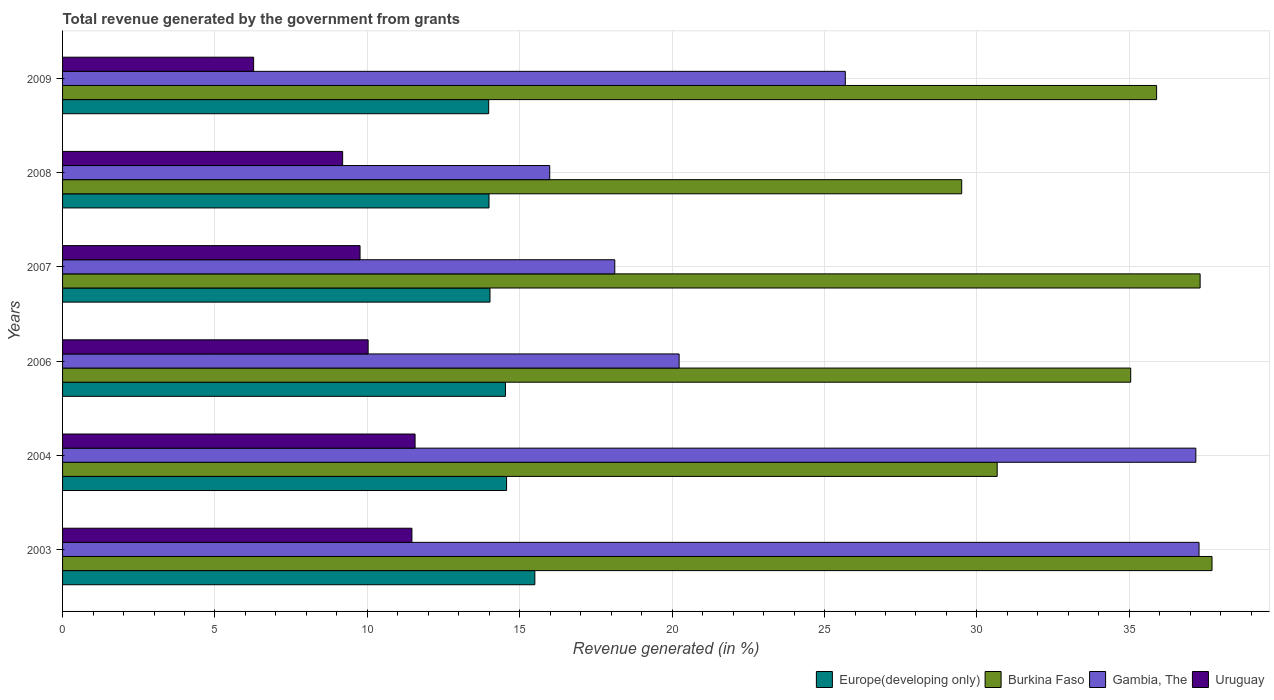How many different coloured bars are there?
Give a very brief answer. 4. Are the number of bars per tick equal to the number of legend labels?
Your response must be concise. Yes. Are the number of bars on each tick of the Y-axis equal?
Give a very brief answer. Yes. How many bars are there on the 4th tick from the top?
Provide a short and direct response. 4. In how many cases, is the number of bars for a given year not equal to the number of legend labels?
Make the answer very short. 0. What is the total revenue generated in Uruguay in 2003?
Your answer should be very brief. 11.46. Across all years, what is the maximum total revenue generated in Burkina Faso?
Ensure brevity in your answer.  37.71. Across all years, what is the minimum total revenue generated in Uruguay?
Give a very brief answer. 6.27. In which year was the total revenue generated in Europe(developing only) minimum?
Provide a succinct answer. 2009. What is the total total revenue generated in Burkina Faso in the graph?
Your response must be concise. 206.14. What is the difference between the total revenue generated in Burkina Faso in 2003 and that in 2006?
Keep it short and to the point. 2.67. What is the difference between the total revenue generated in Gambia, The in 2006 and the total revenue generated in Uruguay in 2007?
Ensure brevity in your answer.  10.47. What is the average total revenue generated in Burkina Faso per year?
Ensure brevity in your answer.  34.36. In the year 2008, what is the difference between the total revenue generated in Uruguay and total revenue generated in Gambia, The?
Your answer should be very brief. -6.79. What is the ratio of the total revenue generated in Gambia, The in 2004 to that in 2007?
Provide a succinct answer. 2.05. Is the total revenue generated in Gambia, The in 2004 less than that in 2009?
Keep it short and to the point. No. What is the difference between the highest and the second highest total revenue generated in Europe(developing only)?
Make the answer very short. 0.93. What is the difference between the highest and the lowest total revenue generated in Gambia, The?
Give a very brief answer. 21.3. Is it the case that in every year, the sum of the total revenue generated in Europe(developing only) and total revenue generated in Uruguay is greater than the sum of total revenue generated in Gambia, The and total revenue generated in Burkina Faso?
Your answer should be compact. No. What does the 1st bar from the top in 2003 represents?
Give a very brief answer. Uruguay. What does the 3rd bar from the bottom in 2008 represents?
Your answer should be very brief. Gambia, The. How many bars are there?
Your answer should be compact. 24. Are all the bars in the graph horizontal?
Offer a terse response. Yes. What is the difference between two consecutive major ticks on the X-axis?
Offer a very short reply. 5. Does the graph contain grids?
Your answer should be very brief. Yes. How many legend labels are there?
Your answer should be very brief. 4. What is the title of the graph?
Your answer should be compact. Total revenue generated by the government from grants. What is the label or title of the X-axis?
Give a very brief answer. Revenue generated (in %). What is the Revenue generated (in %) in Europe(developing only) in 2003?
Your response must be concise. 15.5. What is the Revenue generated (in %) of Burkina Faso in 2003?
Keep it short and to the point. 37.71. What is the Revenue generated (in %) of Gambia, The in 2003?
Provide a short and direct response. 37.29. What is the Revenue generated (in %) of Uruguay in 2003?
Offer a very short reply. 11.46. What is the Revenue generated (in %) in Europe(developing only) in 2004?
Your response must be concise. 14.57. What is the Revenue generated (in %) of Burkina Faso in 2004?
Your answer should be compact. 30.66. What is the Revenue generated (in %) in Gambia, The in 2004?
Provide a succinct answer. 37.18. What is the Revenue generated (in %) of Uruguay in 2004?
Offer a terse response. 11.57. What is the Revenue generated (in %) of Europe(developing only) in 2006?
Offer a terse response. 14.53. What is the Revenue generated (in %) in Burkina Faso in 2006?
Your response must be concise. 35.05. What is the Revenue generated (in %) of Gambia, The in 2006?
Your answer should be very brief. 20.23. What is the Revenue generated (in %) in Uruguay in 2006?
Provide a short and direct response. 10.03. What is the Revenue generated (in %) of Europe(developing only) in 2007?
Make the answer very short. 14.02. What is the Revenue generated (in %) in Burkina Faso in 2007?
Offer a terse response. 37.32. What is the Revenue generated (in %) in Gambia, The in 2007?
Offer a terse response. 18.12. What is the Revenue generated (in %) in Uruguay in 2007?
Make the answer very short. 9.76. What is the Revenue generated (in %) in Europe(developing only) in 2008?
Keep it short and to the point. 13.99. What is the Revenue generated (in %) of Burkina Faso in 2008?
Your response must be concise. 29.5. What is the Revenue generated (in %) in Gambia, The in 2008?
Give a very brief answer. 15.98. What is the Revenue generated (in %) in Uruguay in 2008?
Your response must be concise. 9.19. What is the Revenue generated (in %) of Europe(developing only) in 2009?
Provide a succinct answer. 13.98. What is the Revenue generated (in %) in Burkina Faso in 2009?
Make the answer very short. 35.9. What is the Revenue generated (in %) of Gambia, The in 2009?
Your answer should be compact. 25.68. What is the Revenue generated (in %) of Uruguay in 2009?
Provide a short and direct response. 6.27. Across all years, what is the maximum Revenue generated (in %) in Europe(developing only)?
Offer a very short reply. 15.5. Across all years, what is the maximum Revenue generated (in %) in Burkina Faso?
Your answer should be very brief. 37.71. Across all years, what is the maximum Revenue generated (in %) of Gambia, The?
Provide a succinct answer. 37.29. Across all years, what is the maximum Revenue generated (in %) in Uruguay?
Provide a succinct answer. 11.57. Across all years, what is the minimum Revenue generated (in %) in Europe(developing only)?
Offer a terse response. 13.98. Across all years, what is the minimum Revenue generated (in %) in Burkina Faso?
Provide a short and direct response. 29.5. Across all years, what is the minimum Revenue generated (in %) in Gambia, The?
Keep it short and to the point. 15.98. Across all years, what is the minimum Revenue generated (in %) in Uruguay?
Your answer should be very brief. 6.27. What is the total Revenue generated (in %) in Europe(developing only) in the graph?
Offer a terse response. 86.59. What is the total Revenue generated (in %) in Burkina Faso in the graph?
Offer a terse response. 206.14. What is the total Revenue generated (in %) in Gambia, The in the graph?
Offer a very short reply. 154.48. What is the total Revenue generated (in %) in Uruguay in the graph?
Offer a terse response. 58.27. What is the difference between the Revenue generated (in %) of Europe(developing only) in 2003 and that in 2004?
Your answer should be very brief. 0.93. What is the difference between the Revenue generated (in %) in Burkina Faso in 2003 and that in 2004?
Provide a short and direct response. 7.05. What is the difference between the Revenue generated (in %) of Gambia, The in 2003 and that in 2004?
Your answer should be compact. 0.11. What is the difference between the Revenue generated (in %) of Uruguay in 2003 and that in 2004?
Provide a short and direct response. -0.1. What is the difference between the Revenue generated (in %) in Europe(developing only) in 2003 and that in 2006?
Make the answer very short. 0.96. What is the difference between the Revenue generated (in %) of Burkina Faso in 2003 and that in 2006?
Provide a short and direct response. 2.67. What is the difference between the Revenue generated (in %) of Gambia, The in 2003 and that in 2006?
Give a very brief answer. 17.06. What is the difference between the Revenue generated (in %) in Uruguay in 2003 and that in 2006?
Offer a terse response. 1.44. What is the difference between the Revenue generated (in %) in Europe(developing only) in 2003 and that in 2007?
Ensure brevity in your answer.  1.47. What is the difference between the Revenue generated (in %) of Burkina Faso in 2003 and that in 2007?
Provide a succinct answer. 0.39. What is the difference between the Revenue generated (in %) of Gambia, The in 2003 and that in 2007?
Your answer should be compact. 19.17. What is the difference between the Revenue generated (in %) of Uruguay in 2003 and that in 2007?
Provide a succinct answer. 1.7. What is the difference between the Revenue generated (in %) of Europe(developing only) in 2003 and that in 2008?
Offer a terse response. 1.5. What is the difference between the Revenue generated (in %) in Burkina Faso in 2003 and that in 2008?
Your answer should be compact. 8.21. What is the difference between the Revenue generated (in %) in Gambia, The in 2003 and that in 2008?
Your answer should be very brief. 21.3. What is the difference between the Revenue generated (in %) of Uruguay in 2003 and that in 2008?
Provide a succinct answer. 2.27. What is the difference between the Revenue generated (in %) in Europe(developing only) in 2003 and that in 2009?
Your answer should be compact. 1.51. What is the difference between the Revenue generated (in %) of Burkina Faso in 2003 and that in 2009?
Ensure brevity in your answer.  1.82. What is the difference between the Revenue generated (in %) in Gambia, The in 2003 and that in 2009?
Make the answer very short. 11.61. What is the difference between the Revenue generated (in %) of Uruguay in 2003 and that in 2009?
Make the answer very short. 5.19. What is the difference between the Revenue generated (in %) in Europe(developing only) in 2004 and that in 2006?
Your response must be concise. 0.04. What is the difference between the Revenue generated (in %) in Burkina Faso in 2004 and that in 2006?
Provide a short and direct response. -4.38. What is the difference between the Revenue generated (in %) of Gambia, The in 2004 and that in 2006?
Offer a terse response. 16.95. What is the difference between the Revenue generated (in %) of Uruguay in 2004 and that in 2006?
Ensure brevity in your answer.  1.54. What is the difference between the Revenue generated (in %) in Europe(developing only) in 2004 and that in 2007?
Your answer should be compact. 0.54. What is the difference between the Revenue generated (in %) of Burkina Faso in 2004 and that in 2007?
Your answer should be very brief. -6.66. What is the difference between the Revenue generated (in %) in Gambia, The in 2004 and that in 2007?
Give a very brief answer. 19.06. What is the difference between the Revenue generated (in %) of Uruguay in 2004 and that in 2007?
Provide a succinct answer. 1.81. What is the difference between the Revenue generated (in %) in Europe(developing only) in 2004 and that in 2008?
Your response must be concise. 0.58. What is the difference between the Revenue generated (in %) in Burkina Faso in 2004 and that in 2008?
Your answer should be compact. 1.16. What is the difference between the Revenue generated (in %) in Gambia, The in 2004 and that in 2008?
Keep it short and to the point. 21.2. What is the difference between the Revenue generated (in %) in Uruguay in 2004 and that in 2008?
Keep it short and to the point. 2.38. What is the difference between the Revenue generated (in %) in Europe(developing only) in 2004 and that in 2009?
Your answer should be very brief. 0.59. What is the difference between the Revenue generated (in %) of Burkina Faso in 2004 and that in 2009?
Your answer should be very brief. -5.23. What is the difference between the Revenue generated (in %) of Gambia, The in 2004 and that in 2009?
Keep it short and to the point. 11.5. What is the difference between the Revenue generated (in %) in Uruguay in 2004 and that in 2009?
Provide a short and direct response. 5.3. What is the difference between the Revenue generated (in %) of Europe(developing only) in 2006 and that in 2007?
Make the answer very short. 0.51. What is the difference between the Revenue generated (in %) in Burkina Faso in 2006 and that in 2007?
Provide a short and direct response. -2.28. What is the difference between the Revenue generated (in %) in Gambia, The in 2006 and that in 2007?
Ensure brevity in your answer.  2.11. What is the difference between the Revenue generated (in %) in Uruguay in 2006 and that in 2007?
Your response must be concise. 0.27. What is the difference between the Revenue generated (in %) in Europe(developing only) in 2006 and that in 2008?
Keep it short and to the point. 0.54. What is the difference between the Revenue generated (in %) of Burkina Faso in 2006 and that in 2008?
Make the answer very short. 5.55. What is the difference between the Revenue generated (in %) in Gambia, The in 2006 and that in 2008?
Provide a succinct answer. 4.25. What is the difference between the Revenue generated (in %) in Uruguay in 2006 and that in 2008?
Your answer should be compact. 0.84. What is the difference between the Revenue generated (in %) in Europe(developing only) in 2006 and that in 2009?
Provide a succinct answer. 0.55. What is the difference between the Revenue generated (in %) of Burkina Faso in 2006 and that in 2009?
Ensure brevity in your answer.  -0.85. What is the difference between the Revenue generated (in %) in Gambia, The in 2006 and that in 2009?
Your answer should be very brief. -5.45. What is the difference between the Revenue generated (in %) in Uruguay in 2006 and that in 2009?
Your answer should be very brief. 3.76. What is the difference between the Revenue generated (in %) of Europe(developing only) in 2007 and that in 2008?
Provide a short and direct response. 0.03. What is the difference between the Revenue generated (in %) of Burkina Faso in 2007 and that in 2008?
Your response must be concise. 7.82. What is the difference between the Revenue generated (in %) in Gambia, The in 2007 and that in 2008?
Ensure brevity in your answer.  2.13. What is the difference between the Revenue generated (in %) in Uruguay in 2007 and that in 2008?
Ensure brevity in your answer.  0.57. What is the difference between the Revenue generated (in %) in Europe(developing only) in 2007 and that in 2009?
Give a very brief answer. 0.04. What is the difference between the Revenue generated (in %) of Burkina Faso in 2007 and that in 2009?
Offer a very short reply. 1.43. What is the difference between the Revenue generated (in %) in Gambia, The in 2007 and that in 2009?
Provide a short and direct response. -7.56. What is the difference between the Revenue generated (in %) in Uruguay in 2007 and that in 2009?
Keep it short and to the point. 3.49. What is the difference between the Revenue generated (in %) of Europe(developing only) in 2008 and that in 2009?
Provide a succinct answer. 0.01. What is the difference between the Revenue generated (in %) of Burkina Faso in 2008 and that in 2009?
Offer a terse response. -6.39. What is the difference between the Revenue generated (in %) of Gambia, The in 2008 and that in 2009?
Keep it short and to the point. -9.7. What is the difference between the Revenue generated (in %) of Uruguay in 2008 and that in 2009?
Provide a short and direct response. 2.92. What is the difference between the Revenue generated (in %) of Europe(developing only) in 2003 and the Revenue generated (in %) of Burkina Faso in 2004?
Provide a short and direct response. -15.17. What is the difference between the Revenue generated (in %) in Europe(developing only) in 2003 and the Revenue generated (in %) in Gambia, The in 2004?
Your answer should be compact. -21.69. What is the difference between the Revenue generated (in %) of Europe(developing only) in 2003 and the Revenue generated (in %) of Uruguay in 2004?
Ensure brevity in your answer.  3.93. What is the difference between the Revenue generated (in %) in Burkina Faso in 2003 and the Revenue generated (in %) in Gambia, The in 2004?
Give a very brief answer. 0.53. What is the difference between the Revenue generated (in %) of Burkina Faso in 2003 and the Revenue generated (in %) of Uruguay in 2004?
Provide a short and direct response. 26.15. What is the difference between the Revenue generated (in %) in Gambia, The in 2003 and the Revenue generated (in %) in Uruguay in 2004?
Ensure brevity in your answer.  25.72. What is the difference between the Revenue generated (in %) in Europe(developing only) in 2003 and the Revenue generated (in %) in Burkina Faso in 2006?
Provide a short and direct response. -19.55. What is the difference between the Revenue generated (in %) of Europe(developing only) in 2003 and the Revenue generated (in %) of Gambia, The in 2006?
Your answer should be very brief. -4.73. What is the difference between the Revenue generated (in %) in Europe(developing only) in 2003 and the Revenue generated (in %) in Uruguay in 2006?
Make the answer very short. 5.47. What is the difference between the Revenue generated (in %) of Burkina Faso in 2003 and the Revenue generated (in %) of Gambia, The in 2006?
Give a very brief answer. 17.48. What is the difference between the Revenue generated (in %) in Burkina Faso in 2003 and the Revenue generated (in %) in Uruguay in 2006?
Your answer should be very brief. 27.69. What is the difference between the Revenue generated (in %) of Gambia, The in 2003 and the Revenue generated (in %) of Uruguay in 2006?
Offer a very short reply. 27.26. What is the difference between the Revenue generated (in %) in Europe(developing only) in 2003 and the Revenue generated (in %) in Burkina Faso in 2007?
Provide a succinct answer. -21.83. What is the difference between the Revenue generated (in %) in Europe(developing only) in 2003 and the Revenue generated (in %) in Gambia, The in 2007?
Your answer should be very brief. -2.62. What is the difference between the Revenue generated (in %) in Europe(developing only) in 2003 and the Revenue generated (in %) in Uruguay in 2007?
Your answer should be very brief. 5.73. What is the difference between the Revenue generated (in %) of Burkina Faso in 2003 and the Revenue generated (in %) of Gambia, The in 2007?
Provide a succinct answer. 19.6. What is the difference between the Revenue generated (in %) of Burkina Faso in 2003 and the Revenue generated (in %) of Uruguay in 2007?
Provide a succinct answer. 27.95. What is the difference between the Revenue generated (in %) in Gambia, The in 2003 and the Revenue generated (in %) in Uruguay in 2007?
Make the answer very short. 27.53. What is the difference between the Revenue generated (in %) in Europe(developing only) in 2003 and the Revenue generated (in %) in Burkina Faso in 2008?
Offer a very short reply. -14.01. What is the difference between the Revenue generated (in %) in Europe(developing only) in 2003 and the Revenue generated (in %) in Gambia, The in 2008?
Your answer should be very brief. -0.49. What is the difference between the Revenue generated (in %) of Europe(developing only) in 2003 and the Revenue generated (in %) of Uruguay in 2008?
Keep it short and to the point. 6.31. What is the difference between the Revenue generated (in %) in Burkina Faso in 2003 and the Revenue generated (in %) in Gambia, The in 2008?
Your response must be concise. 21.73. What is the difference between the Revenue generated (in %) of Burkina Faso in 2003 and the Revenue generated (in %) of Uruguay in 2008?
Your answer should be compact. 28.52. What is the difference between the Revenue generated (in %) of Gambia, The in 2003 and the Revenue generated (in %) of Uruguay in 2008?
Offer a very short reply. 28.1. What is the difference between the Revenue generated (in %) in Europe(developing only) in 2003 and the Revenue generated (in %) in Burkina Faso in 2009?
Offer a very short reply. -20.4. What is the difference between the Revenue generated (in %) in Europe(developing only) in 2003 and the Revenue generated (in %) in Gambia, The in 2009?
Your answer should be compact. -10.19. What is the difference between the Revenue generated (in %) in Europe(developing only) in 2003 and the Revenue generated (in %) in Uruguay in 2009?
Provide a succinct answer. 9.23. What is the difference between the Revenue generated (in %) of Burkina Faso in 2003 and the Revenue generated (in %) of Gambia, The in 2009?
Offer a terse response. 12.03. What is the difference between the Revenue generated (in %) of Burkina Faso in 2003 and the Revenue generated (in %) of Uruguay in 2009?
Ensure brevity in your answer.  31.44. What is the difference between the Revenue generated (in %) in Gambia, The in 2003 and the Revenue generated (in %) in Uruguay in 2009?
Give a very brief answer. 31.02. What is the difference between the Revenue generated (in %) in Europe(developing only) in 2004 and the Revenue generated (in %) in Burkina Faso in 2006?
Give a very brief answer. -20.48. What is the difference between the Revenue generated (in %) in Europe(developing only) in 2004 and the Revenue generated (in %) in Gambia, The in 2006?
Ensure brevity in your answer.  -5.66. What is the difference between the Revenue generated (in %) of Europe(developing only) in 2004 and the Revenue generated (in %) of Uruguay in 2006?
Give a very brief answer. 4.54. What is the difference between the Revenue generated (in %) of Burkina Faso in 2004 and the Revenue generated (in %) of Gambia, The in 2006?
Your answer should be very brief. 10.44. What is the difference between the Revenue generated (in %) of Burkina Faso in 2004 and the Revenue generated (in %) of Uruguay in 2006?
Offer a terse response. 20.64. What is the difference between the Revenue generated (in %) of Gambia, The in 2004 and the Revenue generated (in %) of Uruguay in 2006?
Your answer should be compact. 27.16. What is the difference between the Revenue generated (in %) of Europe(developing only) in 2004 and the Revenue generated (in %) of Burkina Faso in 2007?
Offer a terse response. -22.76. What is the difference between the Revenue generated (in %) of Europe(developing only) in 2004 and the Revenue generated (in %) of Gambia, The in 2007?
Your response must be concise. -3.55. What is the difference between the Revenue generated (in %) of Europe(developing only) in 2004 and the Revenue generated (in %) of Uruguay in 2007?
Make the answer very short. 4.81. What is the difference between the Revenue generated (in %) in Burkina Faso in 2004 and the Revenue generated (in %) in Gambia, The in 2007?
Your answer should be compact. 12.55. What is the difference between the Revenue generated (in %) in Burkina Faso in 2004 and the Revenue generated (in %) in Uruguay in 2007?
Offer a terse response. 20.9. What is the difference between the Revenue generated (in %) of Gambia, The in 2004 and the Revenue generated (in %) of Uruguay in 2007?
Give a very brief answer. 27.42. What is the difference between the Revenue generated (in %) in Europe(developing only) in 2004 and the Revenue generated (in %) in Burkina Faso in 2008?
Your answer should be compact. -14.93. What is the difference between the Revenue generated (in %) in Europe(developing only) in 2004 and the Revenue generated (in %) in Gambia, The in 2008?
Give a very brief answer. -1.42. What is the difference between the Revenue generated (in %) of Europe(developing only) in 2004 and the Revenue generated (in %) of Uruguay in 2008?
Ensure brevity in your answer.  5.38. What is the difference between the Revenue generated (in %) in Burkina Faso in 2004 and the Revenue generated (in %) in Gambia, The in 2008?
Provide a short and direct response. 14.68. What is the difference between the Revenue generated (in %) of Burkina Faso in 2004 and the Revenue generated (in %) of Uruguay in 2008?
Make the answer very short. 21.48. What is the difference between the Revenue generated (in %) in Gambia, The in 2004 and the Revenue generated (in %) in Uruguay in 2008?
Keep it short and to the point. 27.99. What is the difference between the Revenue generated (in %) in Europe(developing only) in 2004 and the Revenue generated (in %) in Burkina Faso in 2009?
Offer a very short reply. -21.33. What is the difference between the Revenue generated (in %) of Europe(developing only) in 2004 and the Revenue generated (in %) of Gambia, The in 2009?
Your answer should be compact. -11.11. What is the difference between the Revenue generated (in %) in Europe(developing only) in 2004 and the Revenue generated (in %) in Uruguay in 2009?
Provide a succinct answer. 8.3. What is the difference between the Revenue generated (in %) in Burkina Faso in 2004 and the Revenue generated (in %) in Gambia, The in 2009?
Your response must be concise. 4.98. What is the difference between the Revenue generated (in %) in Burkina Faso in 2004 and the Revenue generated (in %) in Uruguay in 2009?
Ensure brevity in your answer.  24.4. What is the difference between the Revenue generated (in %) in Gambia, The in 2004 and the Revenue generated (in %) in Uruguay in 2009?
Ensure brevity in your answer.  30.91. What is the difference between the Revenue generated (in %) in Europe(developing only) in 2006 and the Revenue generated (in %) in Burkina Faso in 2007?
Your answer should be compact. -22.79. What is the difference between the Revenue generated (in %) in Europe(developing only) in 2006 and the Revenue generated (in %) in Gambia, The in 2007?
Provide a short and direct response. -3.59. What is the difference between the Revenue generated (in %) of Europe(developing only) in 2006 and the Revenue generated (in %) of Uruguay in 2007?
Your answer should be very brief. 4.77. What is the difference between the Revenue generated (in %) of Burkina Faso in 2006 and the Revenue generated (in %) of Gambia, The in 2007?
Keep it short and to the point. 16.93. What is the difference between the Revenue generated (in %) of Burkina Faso in 2006 and the Revenue generated (in %) of Uruguay in 2007?
Keep it short and to the point. 25.29. What is the difference between the Revenue generated (in %) in Gambia, The in 2006 and the Revenue generated (in %) in Uruguay in 2007?
Your answer should be compact. 10.47. What is the difference between the Revenue generated (in %) in Europe(developing only) in 2006 and the Revenue generated (in %) in Burkina Faso in 2008?
Give a very brief answer. -14.97. What is the difference between the Revenue generated (in %) of Europe(developing only) in 2006 and the Revenue generated (in %) of Gambia, The in 2008?
Offer a very short reply. -1.45. What is the difference between the Revenue generated (in %) in Europe(developing only) in 2006 and the Revenue generated (in %) in Uruguay in 2008?
Offer a very short reply. 5.34. What is the difference between the Revenue generated (in %) of Burkina Faso in 2006 and the Revenue generated (in %) of Gambia, The in 2008?
Provide a short and direct response. 19.06. What is the difference between the Revenue generated (in %) of Burkina Faso in 2006 and the Revenue generated (in %) of Uruguay in 2008?
Offer a terse response. 25.86. What is the difference between the Revenue generated (in %) of Gambia, The in 2006 and the Revenue generated (in %) of Uruguay in 2008?
Offer a very short reply. 11.04. What is the difference between the Revenue generated (in %) of Europe(developing only) in 2006 and the Revenue generated (in %) of Burkina Faso in 2009?
Provide a short and direct response. -21.36. What is the difference between the Revenue generated (in %) of Europe(developing only) in 2006 and the Revenue generated (in %) of Gambia, The in 2009?
Your answer should be compact. -11.15. What is the difference between the Revenue generated (in %) of Europe(developing only) in 2006 and the Revenue generated (in %) of Uruguay in 2009?
Your response must be concise. 8.26. What is the difference between the Revenue generated (in %) in Burkina Faso in 2006 and the Revenue generated (in %) in Gambia, The in 2009?
Offer a very short reply. 9.36. What is the difference between the Revenue generated (in %) in Burkina Faso in 2006 and the Revenue generated (in %) in Uruguay in 2009?
Offer a very short reply. 28.78. What is the difference between the Revenue generated (in %) of Gambia, The in 2006 and the Revenue generated (in %) of Uruguay in 2009?
Make the answer very short. 13.96. What is the difference between the Revenue generated (in %) in Europe(developing only) in 2007 and the Revenue generated (in %) in Burkina Faso in 2008?
Keep it short and to the point. -15.48. What is the difference between the Revenue generated (in %) of Europe(developing only) in 2007 and the Revenue generated (in %) of Gambia, The in 2008?
Offer a very short reply. -1.96. What is the difference between the Revenue generated (in %) of Europe(developing only) in 2007 and the Revenue generated (in %) of Uruguay in 2008?
Give a very brief answer. 4.83. What is the difference between the Revenue generated (in %) in Burkina Faso in 2007 and the Revenue generated (in %) in Gambia, The in 2008?
Ensure brevity in your answer.  21.34. What is the difference between the Revenue generated (in %) of Burkina Faso in 2007 and the Revenue generated (in %) of Uruguay in 2008?
Give a very brief answer. 28.13. What is the difference between the Revenue generated (in %) in Gambia, The in 2007 and the Revenue generated (in %) in Uruguay in 2008?
Keep it short and to the point. 8.93. What is the difference between the Revenue generated (in %) in Europe(developing only) in 2007 and the Revenue generated (in %) in Burkina Faso in 2009?
Provide a succinct answer. -21.87. What is the difference between the Revenue generated (in %) of Europe(developing only) in 2007 and the Revenue generated (in %) of Gambia, The in 2009?
Offer a terse response. -11.66. What is the difference between the Revenue generated (in %) in Europe(developing only) in 2007 and the Revenue generated (in %) in Uruguay in 2009?
Make the answer very short. 7.75. What is the difference between the Revenue generated (in %) of Burkina Faso in 2007 and the Revenue generated (in %) of Gambia, The in 2009?
Give a very brief answer. 11.64. What is the difference between the Revenue generated (in %) in Burkina Faso in 2007 and the Revenue generated (in %) in Uruguay in 2009?
Ensure brevity in your answer.  31.05. What is the difference between the Revenue generated (in %) in Gambia, The in 2007 and the Revenue generated (in %) in Uruguay in 2009?
Your response must be concise. 11.85. What is the difference between the Revenue generated (in %) in Europe(developing only) in 2008 and the Revenue generated (in %) in Burkina Faso in 2009?
Make the answer very short. -21.9. What is the difference between the Revenue generated (in %) in Europe(developing only) in 2008 and the Revenue generated (in %) in Gambia, The in 2009?
Offer a terse response. -11.69. What is the difference between the Revenue generated (in %) of Europe(developing only) in 2008 and the Revenue generated (in %) of Uruguay in 2009?
Provide a short and direct response. 7.72. What is the difference between the Revenue generated (in %) of Burkina Faso in 2008 and the Revenue generated (in %) of Gambia, The in 2009?
Keep it short and to the point. 3.82. What is the difference between the Revenue generated (in %) in Burkina Faso in 2008 and the Revenue generated (in %) in Uruguay in 2009?
Make the answer very short. 23.23. What is the difference between the Revenue generated (in %) in Gambia, The in 2008 and the Revenue generated (in %) in Uruguay in 2009?
Offer a very short reply. 9.72. What is the average Revenue generated (in %) in Europe(developing only) per year?
Offer a very short reply. 14.43. What is the average Revenue generated (in %) in Burkina Faso per year?
Provide a short and direct response. 34.36. What is the average Revenue generated (in %) in Gambia, The per year?
Keep it short and to the point. 25.75. What is the average Revenue generated (in %) in Uruguay per year?
Make the answer very short. 9.71. In the year 2003, what is the difference between the Revenue generated (in %) of Europe(developing only) and Revenue generated (in %) of Burkina Faso?
Offer a very short reply. -22.22. In the year 2003, what is the difference between the Revenue generated (in %) of Europe(developing only) and Revenue generated (in %) of Gambia, The?
Give a very brief answer. -21.79. In the year 2003, what is the difference between the Revenue generated (in %) of Europe(developing only) and Revenue generated (in %) of Uruguay?
Your answer should be compact. 4.03. In the year 2003, what is the difference between the Revenue generated (in %) in Burkina Faso and Revenue generated (in %) in Gambia, The?
Your answer should be compact. 0.43. In the year 2003, what is the difference between the Revenue generated (in %) in Burkina Faso and Revenue generated (in %) in Uruguay?
Provide a short and direct response. 26.25. In the year 2003, what is the difference between the Revenue generated (in %) of Gambia, The and Revenue generated (in %) of Uruguay?
Your answer should be compact. 25.83. In the year 2004, what is the difference between the Revenue generated (in %) in Europe(developing only) and Revenue generated (in %) in Burkina Faso?
Make the answer very short. -16.1. In the year 2004, what is the difference between the Revenue generated (in %) of Europe(developing only) and Revenue generated (in %) of Gambia, The?
Make the answer very short. -22.61. In the year 2004, what is the difference between the Revenue generated (in %) of Europe(developing only) and Revenue generated (in %) of Uruguay?
Offer a very short reply. 3. In the year 2004, what is the difference between the Revenue generated (in %) in Burkina Faso and Revenue generated (in %) in Gambia, The?
Your answer should be very brief. -6.52. In the year 2004, what is the difference between the Revenue generated (in %) in Burkina Faso and Revenue generated (in %) in Uruguay?
Keep it short and to the point. 19.1. In the year 2004, what is the difference between the Revenue generated (in %) of Gambia, The and Revenue generated (in %) of Uruguay?
Provide a short and direct response. 25.62. In the year 2006, what is the difference between the Revenue generated (in %) in Europe(developing only) and Revenue generated (in %) in Burkina Faso?
Provide a succinct answer. -20.51. In the year 2006, what is the difference between the Revenue generated (in %) of Europe(developing only) and Revenue generated (in %) of Gambia, The?
Your answer should be very brief. -5.7. In the year 2006, what is the difference between the Revenue generated (in %) of Europe(developing only) and Revenue generated (in %) of Uruguay?
Provide a succinct answer. 4.51. In the year 2006, what is the difference between the Revenue generated (in %) in Burkina Faso and Revenue generated (in %) in Gambia, The?
Give a very brief answer. 14.82. In the year 2006, what is the difference between the Revenue generated (in %) in Burkina Faso and Revenue generated (in %) in Uruguay?
Ensure brevity in your answer.  25.02. In the year 2006, what is the difference between the Revenue generated (in %) of Gambia, The and Revenue generated (in %) of Uruguay?
Ensure brevity in your answer.  10.2. In the year 2007, what is the difference between the Revenue generated (in %) in Europe(developing only) and Revenue generated (in %) in Burkina Faso?
Ensure brevity in your answer.  -23.3. In the year 2007, what is the difference between the Revenue generated (in %) of Europe(developing only) and Revenue generated (in %) of Gambia, The?
Give a very brief answer. -4.09. In the year 2007, what is the difference between the Revenue generated (in %) in Europe(developing only) and Revenue generated (in %) in Uruguay?
Your answer should be compact. 4.26. In the year 2007, what is the difference between the Revenue generated (in %) of Burkina Faso and Revenue generated (in %) of Gambia, The?
Offer a very short reply. 19.21. In the year 2007, what is the difference between the Revenue generated (in %) in Burkina Faso and Revenue generated (in %) in Uruguay?
Offer a very short reply. 27.56. In the year 2007, what is the difference between the Revenue generated (in %) of Gambia, The and Revenue generated (in %) of Uruguay?
Keep it short and to the point. 8.36. In the year 2008, what is the difference between the Revenue generated (in %) in Europe(developing only) and Revenue generated (in %) in Burkina Faso?
Make the answer very short. -15.51. In the year 2008, what is the difference between the Revenue generated (in %) of Europe(developing only) and Revenue generated (in %) of Gambia, The?
Keep it short and to the point. -1.99. In the year 2008, what is the difference between the Revenue generated (in %) of Europe(developing only) and Revenue generated (in %) of Uruguay?
Give a very brief answer. 4.8. In the year 2008, what is the difference between the Revenue generated (in %) in Burkina Faso and Revenue generated (in %) in Gambia, The?
Provide a short and direct response. 13.52. In the year 2008, what is the difference between the Revenue generated (in %) of Burkina Faso and Revenue generated (in %) of Uruguay?
Keep it short and to the point. 20.31. In the year 2008, what is the difference between the Revenue generated (in %) in Gambia, The and Revenue generated (in %) in Uruguay?
Offer a very short reply. 6.79. In the year 2009, what is the difference between the Revenue generated (in %) in Europe(developing only) and Revenue generated (in %) in Burkina Faso?
Provide a short and direct response. -21.91. In the year 2009, what is the difference between the Revenue generated (in %) of Europe(developing only) and Revenue generated (in %) of Gambia, The?
Give a very brief answer. -11.7. In the year 2009, what is the difference between the Revenue generated (in %) of Europe(developing only) and Revenue generated (in %) of Uruguay?
Give a very brief answer. 7.71. In the year 2009, what is the difference between the Revenue generated (in %) of Burkina Faso and Revenue generated (in %) of Gambia, The?
Your answer should be very brief. 10.21. In the year 2009, what is the difference between the Revenue generated (in %) in Burkina Faso and Revenue generated (in %) in Uruguay?
Your answer should be very brief. 29.63. In the year 2009, what is the difference between the Revenue generated (in %) in Gambia, The and Revenue generated (in %) in Uruguay?
Ensure brevity in your answer.  19.41. What is the ratio of the Revenue generated (in %) of Europe(developing only) in 2003 to that in 2004?
Give a very brief answer. 1.06. What is the ratio of the Revenue generated (in %) of Burkina Faso in 2003 to that in 2004?
Offer a very short reply. 1.23. What is the ratio of the Revenue generated (in %) in Europe(developing only) in 2003 to that in 2006?
Your answer should be very brief. 1.07. What is the ratio of the Revenue generated (in %) in Burkina Faso in 2003 to that in 2006?
Make the answer very short. 1.08. What is the ratio of the Revenue generated (in %) in Gambia, The in 2003 to that in 2006?
Ensure brevity in your answer.  1.84. What is the ratio of the Revenue generated (in %) in Uruguay in 2003 to that in 2006?
Offer a terse response. 1.14. What is the ratio of the Revenue generated (in %) of Europe(developing only) in 2003 to that in 2007?
Provide a succinct answer. 1.1. What is the ratio of the Revenue generated (in %) in Burkina Faso in 2003 to that in 2007?
Provide a succinct answer. 1.01. What is the ratio of the Revenue generated (in %) of Gambia, The in 2003 to that in 2007?
Ensure brevity in your answer.  2.06. What is the ratio of the Revenue generated (in %) in Uruguay in 2003 to that in 2007?
Provide a short and direct response. 1.17. What is the ratio of the Revenue generated (in %) in Europe(developing only) in 2003 to that in 2008?
Your response must be concise. 1.11. What is the ratio of the Revenue generated (in %) of Burkina Faso in 2003 to that in 2008?
Your response must be concise. 1.28. What is the ratio of the Revenue generated (in %) of Gambia, The in 2003 to that in 2008?
Give a very brief answer. 2.33. What is the ratio of the Revenue generated (in %) of Uruguay in 2003 to that in 2008?
Ensure brevity in your answer.  1.25. What is the ratio of the Revenue generated (in %) of Europe(developing only) in 2003 to that in 2009?
Give a very brief answer. 1.11. What is the ratio of the Revenue generated (in %) of Burkina Faso in 2003 to that in 2009?
Your answer should be very brief. 1.05. What is the ratio of the Revenue generated (in %) of Gambia, The in 2003 to that in 2009?
Provide a short and direct response. 1.45. What is the ratio of the Revenue generated (in %) of Uruguay in 2003 to that in 2009?
Give a very brief answer. 1.83. What is the ratio of the Revenue generated (in %) of Burkina Faso in 2004 to that in 2006?
Give a very brief answer. 0.88. What is the ratio of the Revenue generated (in %) in Gambia, The in 2004 to that in 2006?
Give a very brief answer. 1.84. What is the ratio of the Revenue generated (in %) of Uruguay in 2004 to that in 2006?
Your answer should be very brief. 1.15. What is the ratio of the Revenue generated (in %) of Europe(developing only) in 2004 to that in 2007?
Give a very brief answer. 1.04. What is the ratio of the Revenue generated (in %) in Burkina Faso in 2004 to that in 2007?
Your answer should be compact. 0.82. What is the ratio of the Revenue generated (in %) of Gambia, The in 2004 to that in 2007?
Provide a short and direct response. 2.05. What is the ratio of the Revenue generated (in %) of Uruguay in 2004 to that in 2007?
Make the answer very short. 1.19. What is the ratio of the Revenue generated (in %) in Europe(developing only) in 2004 to that in 2008?
Your response must be concise. 1.04. What is the ratio of the Revenue generated (in %) of Burkina Faso in 2004 to that in 2008?
Provide a short and direct response. 1.04. What is the ratio of the Revenue generated (in %) of Gambia, The in 2004 to that in 2008?
Offer a terse response. 2.33. What is the ratio of the Revenue generated (in %) of Uruguay in 2004 to that in 2008?
Provide a succinct answer. 1.26. What is the ratio of the Revenue generated (in %) of Europe(developing only) in 2004 to that in 2009?
Keep it short and to the point. 1.04. What is the ratio of the Revenue generated (in %) in Burkina Faso in 2004 to that in 2009?
Keep it short and to the point. 0.85. What is the ratio of the Revenue generated (in %) in Gambia, The in 2004 to that in 2009?
Your answer should be very brief. 1.45. What is the ratio of the Revenue generated (in %) in Uruguay in 2004 to that in 2009?
Your answer should be very brief. 1.84. What is the ratio of the Revenue generated (in %) in Europe(developing only) in 2006 to that in 2007?
Offer a very short reply. 1.04. What is the ratio of the Revenue generated (in %) of Burkina Faso in 2006 to that in 2007?
Offer a terse response. 0.94. What is the ratio of the Revenue generated (in %) in Gambia, The in 2006 to that in 2007?
Provide a short and direct response. 1.12. What is the ratio of the Revenue generated (in %) of Uruguay in 2006 to that in 2007?
Your answer should be very brief. 1.03. What is the ratio of the Revenue generated (in %) in Europe(developing only) in 2006 to that in 2008?
Your response must be concise. 1.04. What is the ratio of the Revenue generated (in %) in Burkina Faso in 2006 to that in 2008?
Give a very brief answer. 1.19. What is the ratio of the Revenue generated (in %) of Gambia, The in 2006 to that in 2008?
Provide a succinct answer. 1.27. What is the ratio of the Revenue generated (in %) of Uruguay in 2006 to that in 2008?
Keep it short and to the point. 1.09. What is the ratio of the Revenue generated (in %) in Europe(developing only) in 2006 to that in 2009?
Your answer should be compact. 1.04. What is the ratio of the Revenue generated (in %) of Burkina Faso in 2006 to that in 2009?
Offer a very short reply. 0.98. What is the ratio of the Revenue generated (in %) of Gambia, The in 2006 to that in 2009?
Provide a succinct answer. 0.79. What is the ratio of the Revenue generated (in %) in Uruguay in 2006 to that in 2009?
Your response must be concise. 1.6. What is the ratio of the Revenue generated (in %) in Burkina Faso in 2007 to that in 2008?
Your answer should be compact. 1.27. What is the ratio of the Revenue generated (in %) in Gambia, The in 2007 to that in 2008?
Keep it short and to the point. 1.13. What is the ratio of the Revenue generated (in %) of Uruguay in 2007 to that in 2008?
Make the answer very short. 1.06. What is the ratio of the Revenue generated (in %) in Europe(developing only) in 2007 to that in 2009?
Keep it short and to the point. 1. What is the ratio of the Revenue generated (in %) of Burkina Faso in 2007 to that in 2009?
Your answer should be compact. 1.04. What is the ratio of the Revenue generated (in %) of Gambia, The in 2007 to that in 2009?
Give a very brief answer. 0.71. What is the ratio of the Revenue generated (in %) of Uruguay in 2007 to that in 2009?
Offer a very short reply. 1.56. What is the ratio of the Revenue generated (in %) of Burkina Faso in 2008 to that in 2009?
Ensure brevity in your answer.  0.82. What is the ratio of the Revenue generated (in %) in Gambia, The in 2008 to that in 2009?
Ensure brevity in your answer.  0.62. What is the ratio of the Revenue generated (in %) of Uruguay in 2008 to that in 2009?
Your answer should be compact. 1.47. What is the difference between the highest and the second highest Revenue generated (in %) of Europe(developing only)?
Make the answer very short. 0.93. What is the difference between the highest and the second highest Revenue generated (in %) of Burkina Faso?
Your answer should be very brief. 0.39. What is the difference between the highest and the second highest Revenue generated (in %) of Gambia, The?
Your response must be concise. 0.11. What is the difference between the highest and the second highest Revenue generated (in %) of Uruguay?
Your answer should be very brief. 0.1. What is the difference between the highest and the lowest Revenue generated (in %) in Europe(developing only)?
Your answer should be compact. 1.51. What is the difference between the highest and the lowest Revenue generated (in %) of Burkina Faso?
Provide a succinct answer. 8.21. What is the difference between the highest and the lowest Revenue generated (in %) of Gambia, The?
Offer a very short reply. 21.3. What is the difference between the highest and the lowest Revenue generated (in %) in Uruguay?
Provide a succinct answer. 5.3. 